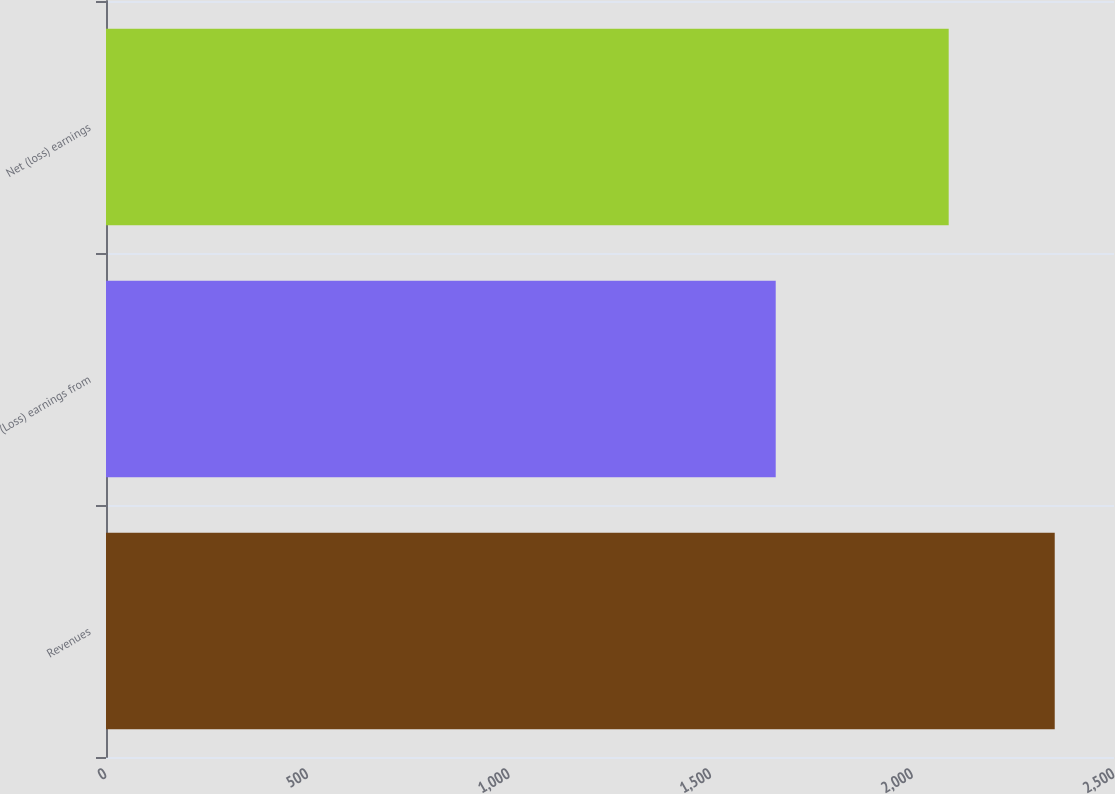Convert chart to OTSL. <chart><loc_0><loc_0><loc_500><loc_500><bar_chart><fcel>Revenues<fcel>(Loss) earnings from<fcel>Net (loss) earnings<nl><fcel>2353<fcel>1661<fcel>2090<nl></chart> 